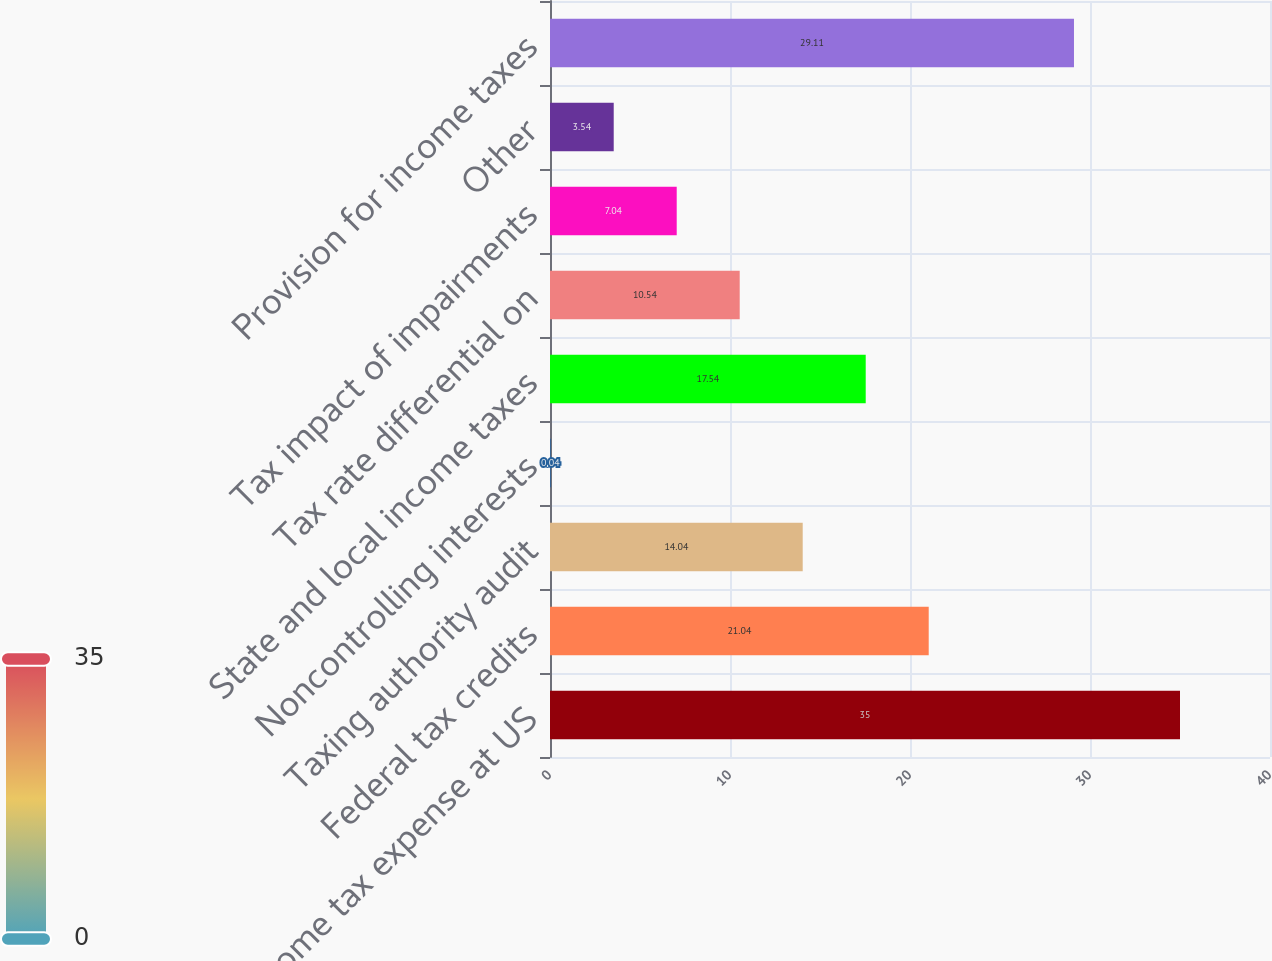Convert chart. <chart><loc_0><loc_0><loc_500><loc_500><bar_chart><fcel>Income tax expense at US<fcel>Federal tax credits<fcel>Taxing authority audit<fcel>Noncontrolling interests<fcel>State and local income taxes<fcel>Tax rate differential on<fcel>Tax impact of impairments<fcel>Other<fcel>Provision for income taxes<nl><fcel>35<fcel>21.04<fcel>14.04<fcel>0.04<fcel>17.54<fcel>10.54<fcel>7.04<fcel>3.54<fcel>29.11<nl></chart> 